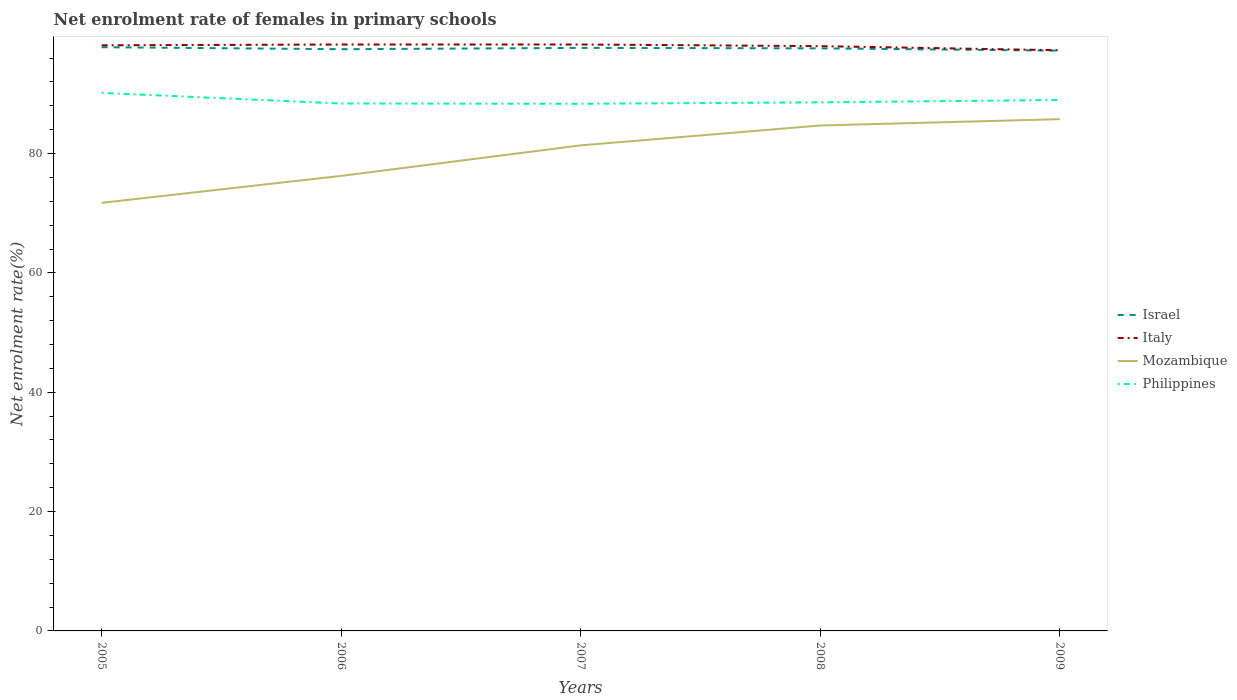How many different coloured lines are there?
Your response must be concise. 4. Does the line corresponding to Philippines intersect with the line corresponding to Israel?
Give a very brief answer. No. Is the number of lines equal to the number of legend labels?
Provide a succinct answer. Yes. Across all years, what is the maximum net enrolment rate of females in primary schools in Philippines?
Ensure brevity in your answer.  88.33. What is the total net enrolment rate of females in primary schools in Italy in the graph?
Offer a terse response. 0.27. What is the difference between the highest and the second highest net enrolment rate of females in primary schools in Italy?
Provide a short and direct response. 0.97. Are the values on the major ticks of Y-axis written in scientific E-notation?
Your response must be concise. No. Does the graph contain any zero values?
Provide a succinct answer. No. How many legend labels are there?
Offer a very short reply. 4. What is the title of the graph?
Make the answer very short. Net enrolment rate of females in primary schools. What is the label or title of the Y-axis?
Make the answer very short. Net enrolment rate(%). What is the Net enrolment rate(%) of Israel in 2005?
Provide a short and direct response. 97.81. What is the Net enrolment rate(%) in Italy in 2005?
Make the answer very short. 98.13. What is the Net enrolment rate(%) in Mozambique in 2005?
Make the answer very short. 71.74. What is the Net enrolment rate(%) of Philippines in 2005?
Your response must be concise. 90.16. What is the Net enrolment rate(%) in Israel in 2006?
Provide a short and direct response. 97.48. What is the Net enrolment rate(%) of Italy in 2006?
Offer a very short reply. 98.27. What is the Net enrolment rate(%) in Mozambique in 2006?
Keep it short and to the point. 76.25. What is the Net enrolment rate(%) of Philippines in 2006?
Keep it short and to the point. 88.38. What is the Net enrolment rate(%) in Israel in 2007?
Your response must be concise. 97.7. What is the Net enrolment rate(%) in Italy in 2007?
Make the answer very short. 98.27. What is the Net enrolment rate(%) of Mozambique in 2007?
Ensure brevity in your answer.  81.37. What is the Net enrolment rate(%) in Philippines in 2007?
Your response must be concise. 88.33. What is the Net enrolment rate(%) in Israel in 2008?
Your answer should be very brief. 97.62. What is the Net enrolment rate(%) of Italy in 2008?
Ensure brevity in your answer.  97.99. What is the Net enrolment rate(%) of Mozambique in 2008?
Your response must be concise. 84.7. What is the Net enrolment rate(%) in Philippines in 2008?
Offer a terse response. 88.58. What is the Net enrolment rate(%) of Israel in 2009?
Make the answer very short. 97.24. What is the Net enrolment rate(%) in Italy in 2009?
Offer a terse response. 97.3. What is the Net enrolment rate(%) in Mozambique in 2009?
Offer a very short reply. 85.76. What is the Net enrolment rate(%) in Philippines in 2009?
Offer a terse response. 88.97. Across all years, what is the maximum Net enrolment rate(%) in Israel?
Your answer should be compact. 97.81. Across all years, what is the maximum Net enrolment rate(%) of Italy?
Your answer should be very brief. 98.27. Across all years, what is the maximum Net enrolment rate(%) in Mozambique?
Make the answer very short. 85.76. Across all years, what is the maximum Net enrolment rate(%) in Philippines?
Your answer should be compact. 90.16. Across all years, what is the minimum Net enrolment rate(%) of Israel?
Keep it short and to the point. 97.24. Across all years, what is the minimum Net enrolment rate(%) of Italy?
Your answer should be compact. 97.3. Across all years, what is the minimum Net enrolment rate(%) of Mozambique?
Your answer should be compact. 71.74. Across all years, what is the minimum Net enrolment rate(%) of Philippines?
Your answer should be compact. 88.33. What is the total Net enrolment rate(%) of Israel in the graph?
Ensure brevity in your answer.  487.86. What is the total Net enrolment rate(%) of Italy in the graph?
Your response must be concise. 489.97. What is the total Net enrolment rate(%) of Mozambique in the graph?
Offer a very short reply. 399.81. What is the total Net enrolment rate(%) of Philippines in the graph?
Your response must be concise. 444.42. What is the difference between the Net enrolment rate(%) in Israel in 2005 and that in 2006?
Your answer should be compact. 0.33. What is the difference between the Net enrolment rate(%) of Italy in 2005 and that in 2006?
Offer a very short reply. -0.13. What is the difference between the Net enrolment rate(%) of Mozambique in 2005 and that in 2006?
Your answer should be compact. -4.52. What is the difference between the Net enrolment rate(%) in Philippines in 2005 and that in 2006?
Ensure brevity in your answer.  1.78. What is the difference between the Net enrolment rate(%) of Israel in 2005 and that in 2007?
Give a very brief answer. 0.11. What is the difference between the Net enrolment rate(%) of Italy in 2005 and that in 2007?
Offer a terse response. -0.14. What is the difference between the Net enrolment rate(%) in Mozambique in 2005 and that in 2007?
Provide a succinct answer. -9.63. What is the difference between the Net enrolment rate(%) in Philippines in 2005 and that in 2007?
Keep it short and to the point. 1.83. What is the difference between the Net enrolment rate(%) in Israel in 2005 and that in 2008?
Give a very brief answer. 0.19. What is the difference between the Net enrolment rate(%) in Italy in 2005 and that in 2008?
Your answer should be compact. 0.14. What is the difference between the Net enrolment rate(%) in Mozambique in 2005 and that in 2008?
Keep it short and to the point. -12.96. What is the difference between the Net enrolment rate(%) of Philippines in 2005 and that in 2008?
Keep it short and to the point. 1.59. What is the difference between the Net enrolment rate(%) of Israel in 2005 and that in 2009?
Your answer should be compact. 0.58. What is the difference between the Net enrolment rate(%) in Italy in 2005 and that in 2009?
Your response must be concise. 0.83. What is the difference between the Net enrolment rate(%) of Mozambique in 2005 and that in 2009?
Your answer should be very brief. -14.02. What is the difference between the Net enrolment rate(%) in Philippines in 2005 and that in 2009?
Keep it short and to the point. 1.2. What is the difference between the Net enrolment rate(%) of Israel in 2006 and that in 2007?
Your answer should be very brief. -0.22. What is the difference between the Net enrolment rate(%) in Italy in 2006 and that in 2007?
Offer a very short reply. -0. What is the difference between the Net enrolment rate(%) of Mozambique in 2006 and that in 2007?
Give a very brief answer. -5.11. What is the difference between the Net enrolment rate(%) of Philippines in 2006 and that in 2007?
Your response must be concise. 0.05. What is the difference between the Net enrolment rate(%) in Israel in 2006 and that in 2008?
Provide a short and direct response. -0.14. What is the difference between the Net enrolment rate(%) in Italy in 2006 and that in 2008?
Your answer should be very brief. 0.27. What is the difference between the Net enrolment rate(%) in Mozambique in 2006 and that in 2008?
Provide a succinct answer. -8.44. What is the difference between the Net enrolment rate(%) of Philippines in 2006 and that in 2008?
Offer a very short reply. -0.2. What is the difference between the Net enrolment rate(%) of Israel in 2006 and that in 2009?
Give a very brief answer. 0.24. What is the difference between the Net enrolment rate(%) of Italy in 2006 and that in 2009?
Your answer should be compact. 0.96. What is the difference between the Net enrolment rate(%) of Mozambique in 2006 and that in 2009?
Make the answer very short. -9.5. What is the difference between the Net enrolment rate(%) of Philippines in 2006 and that in 2009?
Provide a succinct answer. -0.59. What is the difference between the Net enrolment rate(%) in Israel in 2007 and that in 2008?
Offer a terse response. 0.08. What is the difference between the Net enrolment rate(%) of Italy in 2007 and that in 2008?
Your response must be concise. 0.28. What is the difference between the Net enrolment rate(%) of Mozambique in 2007 and that in 2008?
Offer a very short reply. -3.33. What is the difference between the Net enrolment rate(%) in Philippines in 2007 and that in 2008?
Offer a terse response. -0.25. What is the difference between the Net enrolment rate(%) of Israel in 2007 and that in 2009?
Provide a short and direct response. 0.46. What is the difference between the Net enrolment rate(%) in Italy in 2007 and that in 2009?
Give a very brief answer. 0.97. What is the difference between the Net enrolment rate(%) in Mozambique in 2007 and that in 2009?
Provide a succinct answer. -4.39. What is the difference between the Net enrolment rate(%) of Philippines in 2007 and that in 2009?
Provide a succinct answer. -0.63. What is the difference between the Net enrolment rate(%) in Israel in 2008 and that in 2009?
Provide a short and direct response. 0.38. What is the difference between the Net enrolment rate(%) of Italy in 2008 and that in 2009?
Your response must be concise. 0.69. What is the difference between the Net enrolment rate(%) in Mozambique in 2008 and that in 2009?
Provide a short and direct response. -1.06. What is the difference between the Net enrolment rate(%) in Philippines in 2008 and that in 2009?
Make the answer very short. -0.39. What is the difference between the Net enrolment rate(%) of Israel in 2005 and the Net enrolment rate(%) of Italy in 2006?
Give a very brief answer. -0.45. What is the difference between the Net enrolment rate(%) in Israel in 2005 and the Net enrolment rate(%) in Mozambique in 2006?
Give a very brief answer. 21.56. What is the difference between the Net enrolment rate(%) of Israel in 2005 and the Net enrolment rate(%) of Philippines in 2006?
Your answer should be very brief. 9.43. What is the difference between the Net enrolment rate(%) in Italy in 2005 and the Net enrolment rate(%) in Mozambique in 2006?
Provide a succinct answer. 21.88. What is the difference between the Net enrolment rate(%) of Italy in 2005 and the Net enrolment rate(%) of Philippines in 2006?
Offer a terse response. 9.75. What is the difference between the Net enrolment rate(%) of Mozambique in 2005 and the Net enrolment rate(%) of Philippines in 2006?
Give a very brief answer. -16.64. What is the difference between the Net enrolment rate(%) in Israel in 2005 and the Net enrolment rate(%) in Italy in 2007?
Offer a terse response. -0.46. What is the difference between the Net enrolment rate(%) of Israel in 2005 and the Net enrolment rate(%) of Mozambique in 2007?
Your response must be concise. 16.45. What is the difference between the Net enrolment rate(%) of Israel in 2005 and the Net enrolment rate(%) of Philippines in 2007?
Give a very brief answer. 9.48. What is the difference between the Net enrolment rate(%) of Italy in 2005 and the Net enrolment rate(%) of Mozambique in 2007?
Give a very brief answer. 16.77. What is the difference between the Net enrolment rate(%) in Italy in 2005 and the Net enrolment rate(%) in Philippines in 2007?
Provide a succinct answer. 9.8. What is the difference between the Net enrolment rate(%) of Mozambique in 2005 and the Net enrolment rate(%) of Philippines in 2007?
Provide a succinct answer. -16.6. What is the difference between the Net enrolment rate(%) of Israel in 2005 and the Net enrolment rate(%) of Italy in 2008?
Provide a short and direct response. -0.18. What is the difference between the Net enrolment rate(%) in Israel in 2005 and the Net enrolment rate(%) in Mozambique in 2008?
Your answer should be very brief. 13.12. What is the difference between the Net enrolment rate(%) of Israel in 2005 and the Net enrolment rate(%) of Philippines in 2008?
Your answer should be compact. 9.24. What is the difference between the Net enrolment rate(%) of Italy in 2005 and the Net enrolment rate(%) of Mozambique in 2008?
Make the answer very short. 13.44. What is the difference between the Net enrolment rate(%) in Italy in 2005 and the Net enrolment rate(%) in Philippines in 2008?
Keep it short and to the point. 9.56. What is the difference between the Net enrolment rate(%) of Mozambique in 2005 and the Net enrolment rate(%) of Philippines in 2008?
Keep it short and to the point. -16.84. What is the difference between the Net enrolment rate(%) of Israel in 2005 and the Net enrolment rate(%) of Italy in 2009?
Your response must be concise. 0.51. What is the difference between the Net enrolment rate(%) of Israel in 2005 and the Net enrolment rate(%) of Mozambique in 2009?
Provide a short and direct response. 12.06. What is the difference between the Net enrolment rate(%) of Israel in 2005 and the Net enrolment rate(%) of Philippines in 2009?
Provide a short and direct response. 8.85. What is the difference between the Net enrolment rate(%) of Italy in 2005 and the Net enrolment rate(%) of Mozambique in 2009?
Give a very brief answer. 12.38. What is the difference between the Net enrolment rate(%) in Italy in 2005 and the Net enrolment rate(%) in Philippines in 2009?
Make the answer very short. 9.17. What is the difference between the Net enrolment rate(%) in Mozambique in 2005 and the Net enrolment rate(%) in Philippines in 2009?
Give a very brief answer. -17.23. What is the difference between the Net enrolment rate(%) in Israel in 2006 and the Net enrolment rate(%) in Italy in 2007?
Offer a very short reply. -0.79. What is the difference between the Net enrolment rate(%) in Israel in 2006 and the Net enrolment rate(%) in Mozambique in 2007?
Offer a very short reply. 16.11. What is the difference between the Net enrolment rate(%) of Israel in 2006 and the Net enrolment rate(%) of Philippines in 2007?
Your response must be concise. 9.15. What is the difference between the Net enrolment rate(%) in Italy in 2006 and the Net enrolment rate(%) in Mozambique in 2007?
Offer a terse response. 16.9. What is the difference between the Net enrolment rate(%) of Italy in 2006 and the Net enrolment rate(%) of Philippines in 2007?
Your answer should be very brief. 9.94. What is the difference between the Net enrolment rate(%) in Mozambique in 2006 and the Net enrolment rate(%) in Philippines in 2007?
Your response must be concise. -12.08. What is the difference between the Net enrolment rate(%) of Israel in 2006 and the Net enrolment rate(%) of Italy in 2008?
Provide a succinct answer. -0.51. What is the difference between the Net enrolment rate(%) in Israel in 2006 and the Net enrolment rate(%) in Mozambique in 2008?
Provide a succinct answer. 12.78. What is the difference between the Net enrolment rate(%) of Israel in 2006 and the Net enrolment rate(%) of Philippines in 2008?
Your response must be concise. 8.9. What is the difference between the Net enrolment rate(%) of Italy in 2006 and the Net enrolment rate(%) of Mozambique in 2008?
Your response must be concise. 13.57. What is the difference between the Net enrolment rate(%) of Italy in 2006 and the Net enrolment rate(%) of Philippines in 2008?
Provide a succinct answer. 9.69. What is the difference between the Net enrolment rate(%) of Mozambique in 2006 and the Net enrolment rate(%) of Philippines in 2008?
Ensure brevity in your answer.  -12.33. What is the difference between the Net enrolment rate(%) of Israel in 2006 and the Net enrolment rate(%) of Italy in 2009?
Keep it short and to the point. 0.18. What is the difference between the Net enrolment rate(%) in Israel in 2006 and the Net enrolment rate(%) in Mozambique in 2009?
Your response must be concise. 11.72. What is the difference between the Net enrolment rate(%) in Israel in 2006 and the Net enrolment rate(%) in Philippines in 2009?
Your answer should be very brief. 8.51. What is the difference between the Net enrolment rate(%) of Italy in 2006 and the Net enrolment rate(%) of Mozambique in 2009?
Provide a succinct answer. 12.51. What is the difference between the Net enrolment rate(%) in Italy in 2006 and the Net enrolment rate(%) in Philippines in 2009?
Your answer should be compact. 9.3. What is the difference between the Net enrolment rate(%) of Mozambique in 2006 and the Net enrolment rate(%) of Philippines in 2009?
Provide a succinct answer. -12.71. What is the difference between the Net enrolment rate(%) of Israel in 2007 and the Net enrolment rate(%) of Italy in 2008?
Offer a very short reply. -0.29. What is the difference between the Net enrolment rate(%) in Israel in 2007 and the Net enrolment rate(%) in Mozambique in 2008?
Your answer should be very brief. 13. What is the difference between the Net enrolment rate(%) of Israel in 2007 and the Net enrolment rate(%) of Philippines in 2008?
Your response must be concise. 9.12. What is the difference between the Net enrolment rate(%) in Italy in 2007 and the Net enrolment rate(%) in Mozambique in 2008?
Ensure brevity in your answer.  13.57. What is the difference between the Net enrolment rate(%) in Italy in 2007 and the Net enrolment rate(%) in Philippines in 2008?
Provide a succinct answer. 9.69. What is the difference between the Net enrolment rate(%) of Mozambique in 2007 and the Net enrolment rate(%) of Philippines in 2008?
Make the answer very short. -7.21. What is the difference between the Net enrolment rate(%) in Israel in 2007 and the Net enrolment rate(%) in Italy in 2009?
Ensure brevity in your answer.  0.4. What is the difference between the Net enrolment rate(%) in Israel in 2007 and the Net enrolment rate(%) in Mozambique in 2009?
Ensure brevity in your answer.  11.94. What is the difference between the Net enrolment rate(%) in Israel in 2007 and the Net enrolment rate(%) in Philippines in 2009?
Provide a succinct answer. 8.74. What is the difference between the Net enrolment rate(%) of Italy in 2007 and the Net enrolment rate(%) of Mozambique in 2009?
Offer a very short reply. 12.51. What is the difference between the Net enrolment rate(%) of Italy in 2007 and the Net enrolment rate(%) of Philippines in 2009?
Keep it short and to the point. 9.3. What is the difference between the Net enrolment rate(%) in Mozambique in 2007 and the Net enrolment rate(%) in Philippines in 2009?
Give a very brief answer. -7.6. What is the difference between the Net enrolment rate(%) of Israel in 2008 and the Net enrolment rate(%) of Italy in 2009?
Give a very brief answer. 0.32. What is the difference between the Net enrolment rate(%) in Israel in 2008 and the Net enrolment rate(%) in Mozambique in 2009?
Offer a very short reply. 11.87. What is the difference between the Net enrolment rate(%) in Israel in 2008 and the Net enrolment rate(%) in Philippines in 2009?
Ensure brevity in your answer.  8.66. What is the difference between the Net enrolment rate(%) of Italy in 2008 and the Net enrolment rate(%) of Mozambique in 2009?
Your answer should be compact. 12.24. What is the difference between the Net enrolment rate(%) of Italy in 2008 and the Net enrolment rate(%) of Philippines in 2009?
Give a very brief answer. 9.03. What is the difference between the Net enrolment rate(%) of Mozambique in 2008 and the Net enrolment rate(%) of Philippines in 2009?
Make the answer very short. -4.27. What is the average Net enrolment rate(%) in Israel per year?
Ensure brevity in your answer.  97.57. What is the average Net enrolment rate(%) in Italy per year?
Make the answer very short. 97.99. What is the average Net enrolment rate(%) in Mozambique per year?
Give a very brief answer. 79.96. What is the average Net enrolment rate(%) of Philippines per year?
Keep it short and to the point. 88.88. In the year 2005, what is the difference between the Net enrolment rate(%) in Israel and Net enrolment rate(%) in Italy?
Provide a short and direct response. -0.32. In the year 2005, what is the difference between the Net enrolment rate(%) in Israel and Net enrolment rate(%) in Mozambique?
Make the answer very short. 26.08. In the year 2005, what is the difference between the Net enrolment rate(%) in Israel and Net enrolment rate(%) in Philippines?
Your answer should be very brief. 7.65. In the year 2005, what is the difference between the Net enrolment rate(%) in Italy and Net enrolment rate(%) in Mozambique?
Your answer should be very brief. 26.4. In the year 2005, what is the difference between the Net enrolment rate(%) in Italy and Net enrolment rate(%) in Philippines?
Provide a short and direct response. 7.97. In the year 2005, what is the difference between the Net enrolment rate(%) in Mozambique and Net enrolment rate(%) in Philippines?
Give a very brief answer. -18.43. In the year 2006, what is the difference between the Net enrolment rate(%) in Israel and Net enrolment rate(%) in Italy?
Provide a short and direct response. -0.79. In the year 2006, what is the difference between the Net enrolment rate(%) in Israel and Net enrolment rate(%) in Mozambique?
Your answer should be compact. 21.23. In the year 2006, what is the difference between the Net enrolment rate(%) in Israel and Net enrolment rate(%) in Philippines?
Offer a terse response. 9.1. In the year 2006, what is the difference between the Net enrolment rate(%) in Italy and Net enrolment rate(%) in Mozambique?
Ensure brevity in your answer.  22.02. In the year 2006, what is the difference between the Net enrolment rate(%) of Italy and Net enrolment rate(%) of Philippines?
Offer a terse response. 9.89. In the year 2006, what is the difference between the Net enrolment rate(%) of Mozambique and Net enrolment rate(%) of Philippines?
Provide a succinct answer. -12.13. In the year 2007, what is the difference between the Net enrolment rate(%) in Israel and Net enrolment rate(%) in Italy?
Offer a terse response. -0.57. In the year 2007, what is the difference between the Net enrolment rate(%) in Israel and Net enrolment rate(%) in Mozambique?
Ensure brevity in your answer.  16.33. In the year 2007, what is the difference between the Net enrolment rate(%) of Israel and Net enrolment rate(%) of Philippines?
Offer a terse response. 9.37. In the year 2007, what is the difference between the Net enrolment rate(%) of Italy and Net enrolment rate(%) of Mozambique?
Give a very brief answer. 16.9. In the year 2007, what is the difference between the Net enrolment rate(%) in Italy and Net enrolment rate(%) in Philippines?
Provide a short and direct response. 9.94. In the year 2007, what is the difference between the Net enrolment rate(%) in Mozambique and Net enrolment rate(%) in Philippines?
Your answer should be compact. -6.97. In the year 2008, what is the difference between the Net enrolment rate(%) of Israel and Net enrolment rate(%) of Italy?
Give a very brief answer. -0.37. In the year 2008, what is the difference between the Net enrolment rate(%) in Israel and Net enrolment rate(%) in Mozambique?
Provide a succinct answer. 12.93. In the year 2008, what is the difference between the Net enrolment rate(%) of Israel and Net enrolment rate(%) of Philippines?
Provide a succinct answer. 9.05. In the year 2008, what is the difference between the Net enrolment rate(%) in Italy and Net enrolment rate(%) in Mozambique?
Your response must be concise. 13.3. In the year 2008, what is the difference between the Net enrolment rate(%) in Italy and Net enrolment rate(%) in Philippines?
Offer a terse response. 9.42. In the year 2008, what is the difference between the Net enrolment rate(%) in Mozambique and Net enrolment rate(%) in Philippines?
Make the answer very short. -3.88. In the year 2009, what is the difference between the Net enrolment rate(%) in Israel and Net enrolment rate(%) in Italy?
Offer a terse response. -0.07. In the year 2009, what is the difference between the Net enrolment rate(%) in Israel and Net enrolment rate(%) in Mozambique?
Give a very brief answer. 11.48. In the year 2009, what is the difference between the Net enrolment rate(%) of Israel and Net enrolment rate(%) of Philippines?
Give a very brief answer. 8.27. In the year 2009, what is the difference between the Net enrolment rate(%) of Italy and Net enrolment rate(%) of Mozambique?
Offer a very short reply. 11.55. In the year 2009, what is the difference between the Net enrolment rate(%) in Italy and Net enrolment rate(%) in Philippines?
Provide a short and direct response. 8.34. In the year 2009, what is the difference between the Net enrolment rate(%) of Mozambique and Net enrolment rate(%) of Philippines?
Your answer should be very brief. -3.21. What is the ratio of the Net enrolment rate(%) of Italy in 2005 to that in 2006?
Offer a very short reply. 1. What is the ratio of the Net enrolment rate(%) of Mozambique in 2005 to that in 2006?
Offer a very short reply. 0.94. What is the ratio of the Net enrolment rate(%) of Philippines in 2005 to that in 2006?
Make the answer very short. 1.02. What is the ratio of the Net enrolment rate(%) of Israel in 2005 to that in 2007?
Provide a short and direct response. 1. What is the ratio of the Net enrolment rate(%) in Italy in 2005 to that in 2007?
Provide a succinct answer. 1. What is the ratio of the Net enrolment rate(%) of Mozambique in 2005 to that in 2007?
Keep it short and to the point. 0.88. What is the ratio of the Net enrolment rate(%) of Philippines in 2005 to that in 2007?
Provide a short and direct response. 1.02. What is the ratio of the Net enrolment rate(%) in Israel in 2005 to that in 2008?
Your answer should be compact. 1. What is the ratio of the Net enrolment rate(%) of Italy in 2005 to that in 2008?
Offer a very short reply. 1. What is the ratio of the Net enrolment rate(%) of Mozambique in 2005 to that in 2008?
Provide a short and direct response. 0.85. What is the ratio of the Net enrolment rate(%) in Philippines in 2005 to that in 2008?
Keep it short and to the point. 1.02. What is the ratio of the Net enrolment rate(%) of Israel in 2005 to that in 2009?
Your answer should be compact. 1.01. What is the ratio of the Net enrolment rate(%) in Italy in 2005 to that in 2009?
Provide a succinct answer. 1.01. What is the ratio of the Net enrolment rate(%) of Mozambique in 2005 to that in 2009?
Provide a succinct answer. 0.84. What is the ratio of the Net enrolment rate(%) of Philippines in 2005 to that in 2009?
Your response must be concise. 1.01. What is the ratio of the Net enrolment rate(%) in Italy in 2006 to that in 2007?
Your answer should be compact. 1. What is the ratio of the Net enrolment rate(%) of Mozambique in 2006 to that in 2007?
Ensure brevity in your answer.  0.94. What is the ratio of the Net enrolment rate(%) in Philippines in 2006 to that in 2007?
Provide a succinct answer. 1. What is the ratio of the Net enrolment rate(%) in Italy in 2006 to that in 2008?
Keep it short and to the point. 1. What is the ratio of the Net enrolment rate(%) of Mozambique in 2006 to that in 2008?
Ensure brevity in your answer.  0.9. What is the ratio of the Net enrolment rate(%) in Italy in 2006 to that in 2009?
Your answer should be very brief. 1.01. What is the ratio of the Net enrolment rate(%) of Mozambique in 2006 to that in 2009?
Give a very brief answer. 0.89. What is the ratio of the Net enrolment rate(%) of Philippines in 2006 to that in 2009?
Keep it short and to the point. 0.99. What is the ratio of the Net enrolment rate(%) in Israel in 2007 to that in 2008?
Provide a short and direct response. 1. What is the ratio of the Net enrolment rate(%) of Italy in 2007 to that in 2008?
Your answer should be compact. 1. What is the ratio of the Net enrolment rate(%) in Mozambique in 2007 to that in 2008?
Your answer should be compact. 0.96. What is the ratio of the Net enrolment rate(%) in Philippines in 2007 to that in 2008?
Offer a very short reply. 1. What is the ratio of the Net enrolment rate(%) of Italy in 2007 to that in 2009?
Your answer should be compact. 1.01. What is the ratio of the Net enrolment rate(%) in Mozambique in 2007 to that in 2009?
Provide a succinct answer. 0.95. What is the ratio of the Net enrolment rate(%) of Philippines in 2007 to that in 2009?
Your answer should be compact. 0.99. What is the ratio of the Net enrolment rate(%) in Italy in 2008 to that in 2009?
Keep it short and to the point. 1.01. What is the ratio of the Net enrolment rate(%) of Mozambique in 2008 to that in 2009?
Make the answer very short. 0.99. What is the ratio of the Net enrolment rate(%) in Philippines in 2008 to that in 2009?
Provide a short and direct response. 1. What is the difference between the highest and the second highest Net enrolment rate(%) of Israel?
Offer a very short reply. 0.11. What is the difference between the highest and the second highest Net enrolment rate(%) of Italy?
Make the answer very short. 0. What is the difference between the highest and the second highest Net enrolment rate(%) in Mozambique?
Make the answer very short. 1.06. What is the difference between the highest and the second highest Net enrolment rate(%) of Philippines?
Your answer should be very brief. 1.2. What is the difference between the highest and the lowest Net enrolment rate(%) of Israel?
Your answer should be very brief. 0.58. What is the difference between the highest and the lowest Net enrolment rate(%) in Italy?
Keep it short and to the point. 0.97. What is the difference between the highest and the lowest Net enrolment rate(%) in Mozambique?
Offer a terse response. 14.02. What is the difference between the highest and the lowest Net enrolment rate(%) of Philippines?
Offer a very short reply. 1.83. 